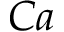<formula> <loc_0><loc_0><loc_500><loc_500>C a</formula> 